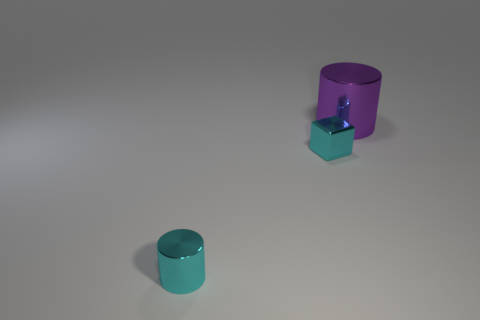Add 1 large red spheres. How many objects exist? 4 Subtract all cylinders. How many objects are left? 1 Add 3 tiny things. How many tiny things exist? 5 Subtract 1 purple cylinders. How many objects are left? 2 Subtract all cyan metallic cylinders. Subtract all small purple rubber blocks. How many objects are left? 2 Add 3 big purple metal cylinders. How many big purple metal cylinders are left? 4 